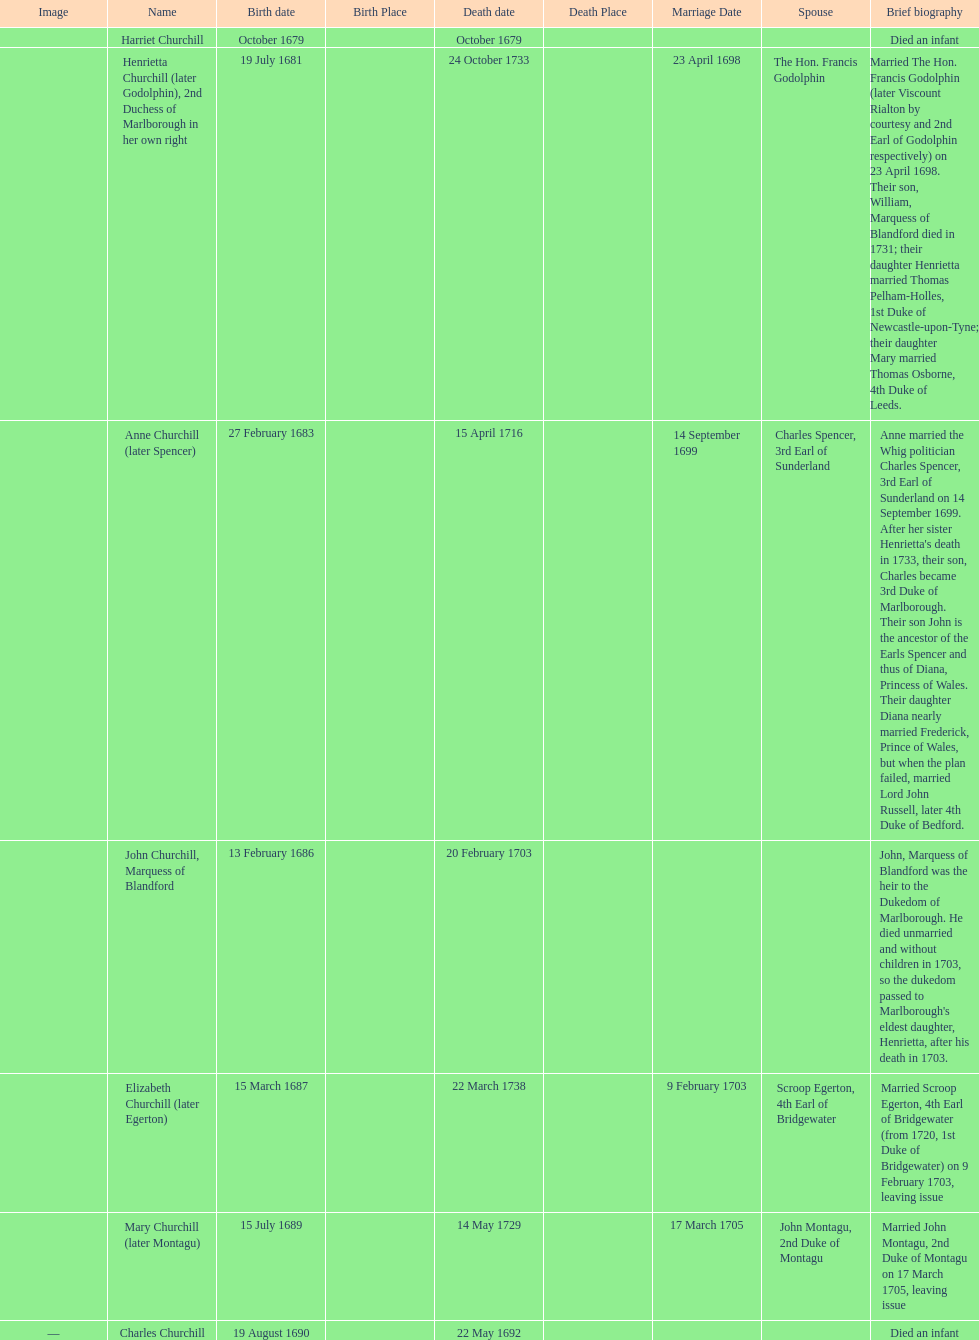What is the total number of children born after 1675? 7. 